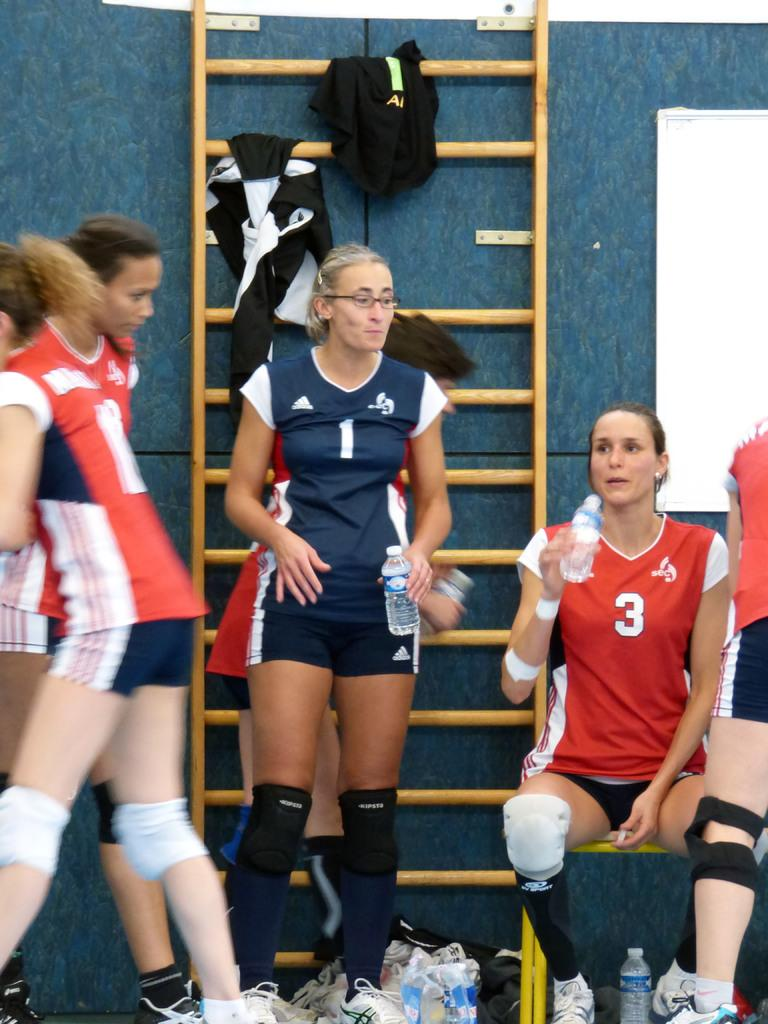<image>
Provide a brief description of the given image. A female athlete, with the number 3 on the front of her jersey is sitting down, drinking water next to a woman in blue, also drinking water. 